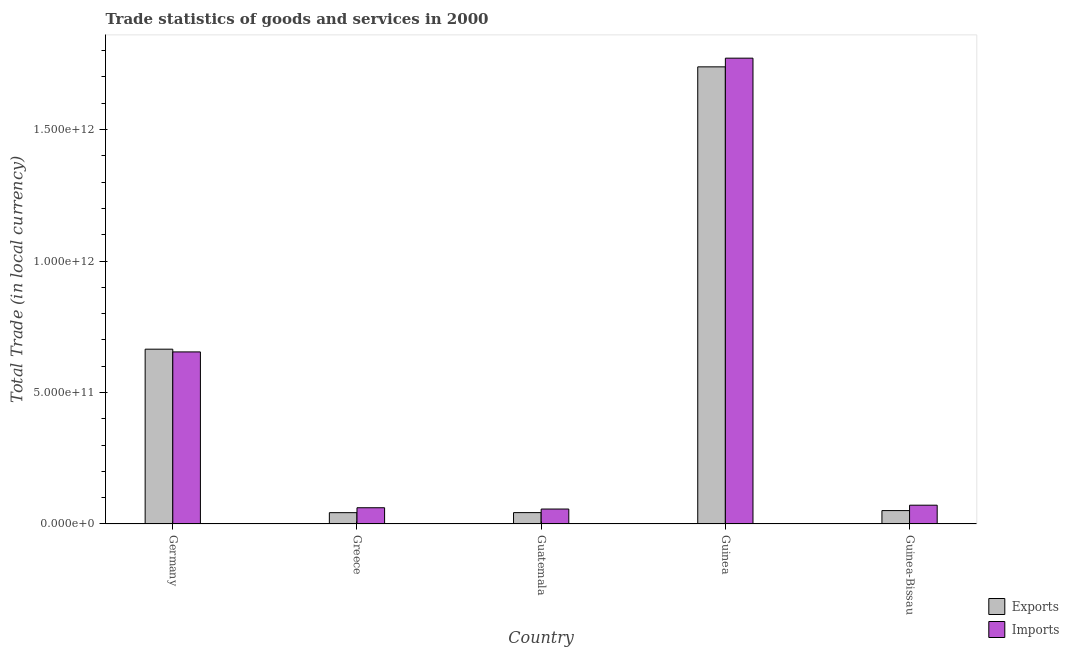How many bars are there on the 1st tick from the left?
Give a very brief answer. 2. What is the label of the 5th group of bars from the left?
Offer a very short reply. Guinea-Bissau. What is the export of goods and services in Guinea?
Give a very brief answer. 1.74e+12. Across all countries, what is the maximum imports of goods and services?
Offer a terse response. 1.77e+12. Across all countries, what is the minimum export of goods and services?
Make the answer very short. 4.30e+1. In which country was the export of goods and services maximum?
Provide a short and direct response. Guinea. In which country was the imports of goods and services minimum?
Your answer should be very brief. Guatemala. What is the total imports of goods and services in the graph?
Provide a short and direct response. 2.62e+12. What is the difference between the export of goods and services in Guatemala and that in Guinea-Bissau?
Give a very brief answer. -7.74e+09. What is the difference between the imports of goods and services in Guatemala and the export of goods and services in Greece?
Make the answer very short. 1.38e+1. What is the average export of goods and services per country?
Keep it short and to the point. 5.08e+11. What is the difference between the export of goods and services and imports of goods and services in Guatemala?
Keep it short and to the point. -1.36e+1. In how many countries, is the export of goods and services greater than 500000000000 LCU?
Provide a short and direct response. 2. What is the ratio of the export of goods and services in Germany to that in Guinea?
Make the answer very short. 0.38. Is the difference between the export of goods and services in Germany and Guatemala greater than the difference between the imports of goods and services in Germany and Guatemala?
Your response must be concise. Yes. What is the difference between the highest and the second highest export of goods and services?
Your answer should be very brief. 1.07e+12. What is the difference between the highest and the lowest imports of goods and services?
Ensure brevity in your answer.  1.71e+12. What does the 1st bar from the left in Guinea-Bissau represents?
Offer a very short reply. Exports. What does the 1st bar from the right in Guinea-Bissau represents?
Offer a very short reply. Imports. Are all the bars in the graph horizontal?
Offer a terse response. No. How many countries are there in the graph?
Keep it short and to the point. 5. What is the difference between two consecutive major ticks on the Y-axis?
Your response must be concise. 5.00e+11. Does the graph contain any zero values?
Make the answer very short. No. Does the graph contain grids?
Keep it short and to the point. No. How many legend labels are there?
Provide a succinct answer. 2. How are the legend labels stacked?
Provide a succinct answer. Vertical. What is the title of the graph?
Make the answer very short. Trade statistics of goods and services in 2000. What is the label or title of the Y-axis?
Offer a very short reply. Total Trade (in local currency). What is the Total Trade (in local currency) of Exports in Germany?
Your response must be concise. 6.65e+11. What is the Total Trade (in local currency) of Imports in Germany?
Your response must be concise. 6.54e+11. What is the Total Trade (in local currency) of Exports in Greece?
Keep it short and to the point. 4.30e+1. What is the Total Trade (in local currency) in Imports in Greece?
Ensure brevity in your answer.  6.17e+1. What is the Total Trade (in local currency) in Exports in Guatemala?
Ensure brevity in your answer.  4.32e+1. What is the Total Trade (in local currency) in Imports in Guatemala?
Your response must be concise. 5.68e+1. What is the Total Trade (in local currency) of Exports in Guinea?
Keep it short and to the point. 1.74e+12. What is the Total Trade (in local currency) of Imports in Guinea?
Offer a very short reply. 1.77e+12. What is the Total Trade (in local currency) in Exports in Guinea-Bissau?
Provide a short and direct response. 5.09e+1. What is the Total Trade (in local currency) of Imports in Guinea-Bissau?
Make the answer very short. 7.15e+1. Across all countries, what is the maximum Total Trade (in local currency) of Exports?
Provide a succinct answer. 1.74e+12. Across all countries, what is the maximum Total Trade (in local currency) in Imports?
Your response must be concise. 1.77e+12. Across all countries, what is the minimum Total Trade (in local currency) in Exports?
Keep it short and to the point. 4.30e+1. Across all countries, what is the minimum Total Trade (in local currency) of Imports?
Provide a short and direct response. 5.68e+1. What is the total Total Trade (in local currency) of Exports in the graph?
Provide a short and direct response. 2.54e+12. What is the total Total Trade (in local currency) of Imports in the graph?
Give a very brief answer. 2.62e+12. What is the difference between the Total Trade (in local currency) of Exports in Germany and that in Greece?
Your response must be concise. 6.22e+11. What is the difference between the Total Trade (in local currency) in Imports in Germany and that in Greece?
Give a very brief answer. 5.93e+11. What is the difference between the Total Trade (in local currency) in Exports in Germany and that in Guatemala?
Ensure brevity in your answer.  6.22e+11. What is the difference between the Total Trade (in local currency) of Imports in Germany and that in Guatemala?
Ensure brevity in your answer.  5.98e+11. What is the difference between the Total Trade (in local currency) in Exports in Germany and that in Guinea?
Your response must be concise. -1.07e+12. What is the difference between the Total Trade (in local currency) in Imports in Germany and that in Guinea?
Your answer should be very brief. -1.12e+12. What is the difference between the Total Trade (in local currency) in Exports in Germany and that in Guinea-Bissau?
Give a very brief answer. 6.14e+11. What is the difference between the Total Trade (in local currency) in Imports in Germany and that in Guinea-Bissau?
Offer a very short reply. 5.83e+11. What is the difference between the Total Trade (in local currency) of Exports in Greece and that in Guatemala?
Your response must be concise. -1.53e+08. What is the difference between the Total Trade (in local currency) of Imports in Greece and that in Guatemala?
Provide a short and direct response. 4.92e+09. What is the difference between the Total Trade (in local currency) in Exports in Greece and that in Guinea?
Offer a very short reply. -1.70e+12. What is the difference between the Total Trade (in local currency) in Imports in Greece and that in Guinea?
Provide a succinct answer. -1.71e+12. What is the difference between the Total Trade (in local currency) in Exports in Greece and that in Guinea-Bissau?
Give a very brief answer. -7.90e+09. What is the difference between the Total Trade (in local currency) of Imports in Greece and that in Guinea-Bissau?
Keep it short and to the point. -9.71e+09. What is the difference between the Total Trade (in local currency) of Exports in Guatemala and that in Guinea?
Give a very brief answer. -1.70e+12. What is the difference between the Total Trade (in local currency) of Imports in Guatemala and that in Guinea?
Make the answer very short. -1.71e+12. What is the difference between the Total Trade (in local currency) of Exports in Guatemala and that in Guinea-Bissau?
Your answer should be very brief. -7.74e+09. What is the difference between the Total Trade (in local currency) of Imports in Guatemala and that in Guinea-Bissau?
Offer a very short reply. -1.46e+1. What is the difference between the Total Trade (in local currency) in Exports in Guinea and that in Guinea-Bissau?
Offer a terse response. 1.69e+12. What is the difference between the Total Trade (in local currency) of Imports in Guinea and that in Guinea-Bissau?
Provide a succinct answer. 1.70e+12. What is the difference between the Total Trade (in local currency) of Exports in Germany and the Total Trade (in local currency) of Imports in Greece?
Provide a short and direct response. 6.03e+11. What is the difference between the Total Trade (in local currency) of Exports in Germany and the Total Trade (in local currency) of Imports in Guatemala?
Provide a short and direct response. 6.08e+11. What is the difference between the Total Trade (in local currency) in Exports in Germany and the Total Trade (in local currency) in Imports in Guinea?
Offer a very short reply. -1.11e+12. What is the difference between the Total Trade (in local currency) of Exports in Germany and the Total Trade (in local currency) of Imports in Guinea-Bissau?
Your response must be concise. 5.93e+11. What is the difference between the Total Trade (in local currency) of Exports in Greece and the Total Trade (in local currency) of Imports in Guatemala?
Offer a terse response. -1.38e+1. What is the difference between the Total Trade (in local currency) of Exports in Greece and the Total Trade (in local currency) of Imports in Guinea?
Offer a terse response. -1.73e+12. What is the difference between the Total Trade (in local currency) in Exports in Greece and the Total Trade (in local currency) in Imports in Guinea-Bissau?
Make the answer very short. -2.84e+1. What is the difference between the Total Trade (in local currency) in Exports in Guatemala and the Total Trade (in local currency) in Imports in Guinea?
Make the answer very short. -1.73e+12. What is the difference between the Total Trade (in local currency) in Exports in Guatemala and the Total Trade (in local currency) in Imports in Guinea-Bissau?
Provide a succinct answer. -2.83e+1. What is the difference between the Total Trade (in local currency) of Exports in Guinea and the Total Trade (in local currency) of Imports in Guinea-Bissau?
Make the answer very short. 1.67e+12. What is the average Total Trade (in local currency) in Exports per country?
Give a very brief answer. 5.08e+11. What is the average Total Trade (in local currency) of Imports per country?
Provide a short and direct response. 5.23e+11. What is the difference between the Total Trade (in local currency) in Exports and Total Trade (in local currency) in Imports in Germany?
Ensure brevity in your answer.  1.04e+1. What is the difference between the Total Trade (in local currency) of Exports and Total Trade (in local currency) of Imports in Greece?
Give a very brief answer. -1.87e+1. What is the difference between the Total Trade (in local currency) in Exports and Total Trade (in local currency) in Imports in Guatemala?
Provide a short and direct response. -1.36e+1. What is the difference between the Total Trade (in local currency) of Exports and Total Trade (in local currency) of Imports in Guinea?
Provide a succinct answer. -3.30e+1. What is the difference between the Total Trade (in local currency) in Exports and Total Trade (in local currency) in Imports in Guinea-Bissau?
Your answer should be compact. -2.05e+1. What is the ratio of the Total Trade (in local currency) of Exports in Germany to that in Greece?
Ensure brevity in your answer.  15.45. What is the ratio of the Total Trade (in local currency) in Imports in Germany to that in Greece?
Your answer should be compact. 10.6. What is the ratio of the Total Trade (in local currency) of Exports in Germany to that in Guatemala?
Give a very brief answer. 15.39. What is the ratio of the Total Trade (in local currency) in Imports in Germany to that in Guatemala?
Give a very brief answer. 11.52. What is the ratio of the Total Trade (in local currency) of Exports in Germany to that in Guinea?
Provide a succinct answer. 0.38. What is the ratio of the Total Trade (in local currency) in Imports in Germany to that in Guinea?
Offer a very short reply. 0.37. What is the ratio of the Total Trade (in local currency) of Exports in Germany to that in Guinea-Bissau?
Provide a succinct answer. 13.05. What is the ratio of the Total Trade (in local currency) of Imports in Germany to that in Guinea-Bissau?
Offer a very short reply. 9.16. What is the ratio of the Total Trade (in local currency) in Exports in Greece to that in Guatemala?
Offer a very short reply. 1. What is the ratio of the Total Trade (in local currency) in Imports in Greece to that in Guatemala?
Keep it short and to the point. 1.09. What is the ratio of the Total Trade (in local currency) in Exports in Greece to that in Guinea?
Ensure brevity in your answer.  0.02. What is the ratio of the Total Trade (in local currency) in Imports in Greece to that in Guinea?
Your answer should be very brief. 0.03. What is the ratio of the Total Trade (in local currency) in Exports in Greece to that in Guinea-Bissau?
Ensure brevity in your answer.  0.84. What is the ratio of the Total Trade (in local currency) in Imports in Greece to that in Guinea-Bissau?
Your response must be concise. 0.86. What is the ratio of the Total Trade (in local currency) of Exports in Guatemala to that in Guinea?
Keep it short and to the point. 0.02. What is the ratio of the Total Trade (in local currency) of Imports in Guatemala to that in Guinea?
Your response must be concise. 0.03. What is the ratio of the Total Trade (in local currency) in Exports in Guatemala to that in Guinea-Bissau?
Offer a terse response. 0.85. What is the ratio of the Total Trade (in local currency) in Imports in Guatemala to that in Guinea-Bissau?
Keep it short and to the point. 0.8. What is the ratio of the Total Trade (in local currency) in Exports in Guinea to that in Guinea-Bissau?
Give a very brief answer. 34.14. What is the ratio of the Total Trade (in local currency) of Imports in Guinea to that in Guinea-Bissau?
Keep it short and to the point. 24.79. What is the difference between the highest and the second highest Total Trade (in local currency) in Exports?
Give a very brief answer. 1.07e+12. What is the difference between the highest and the second highest Total Trade (in local currency) of Imports?
Offer a very short reply. 1.12e+12. What is the difference between the highest and the lowest Total Trade (in local currency) in Exports?
Give a very brief answer. 1.70e+12. What is the difference between the highest and the lowest Total Trade (in local currency) in Imports?
Offer a terse response. 1.71e+12. 